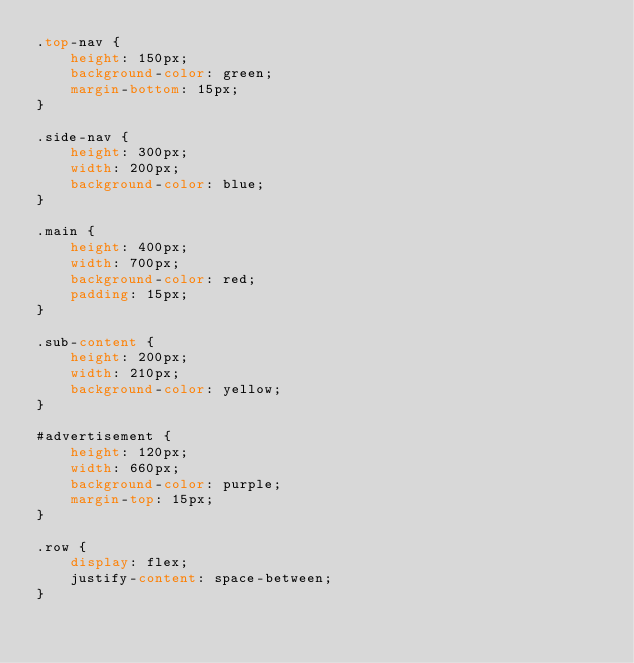<code> <loc_0><loc_0><loc_500><loc_500><_CSS_>.top-nav {
    height: 150px;
    background-color: green;
    margin-bottom: 15px;
}

.side-nav {
    height: 300px;
    width: 200px;
    background-color: blue;
}

.main {
    height: 400px;
    width: 700px;
    background-color: red;
    padding: 15px;
}

.sub-content {
    height: 200px;
    width: 210px;
    background-color: yellow;
}

#advertisement {
    height: 120px;
    width: 660px;
    background-color: purple;
    margin-top: 15px;
}

.row {
    display: flex;
    justify-content: space-between;
}

</code> 